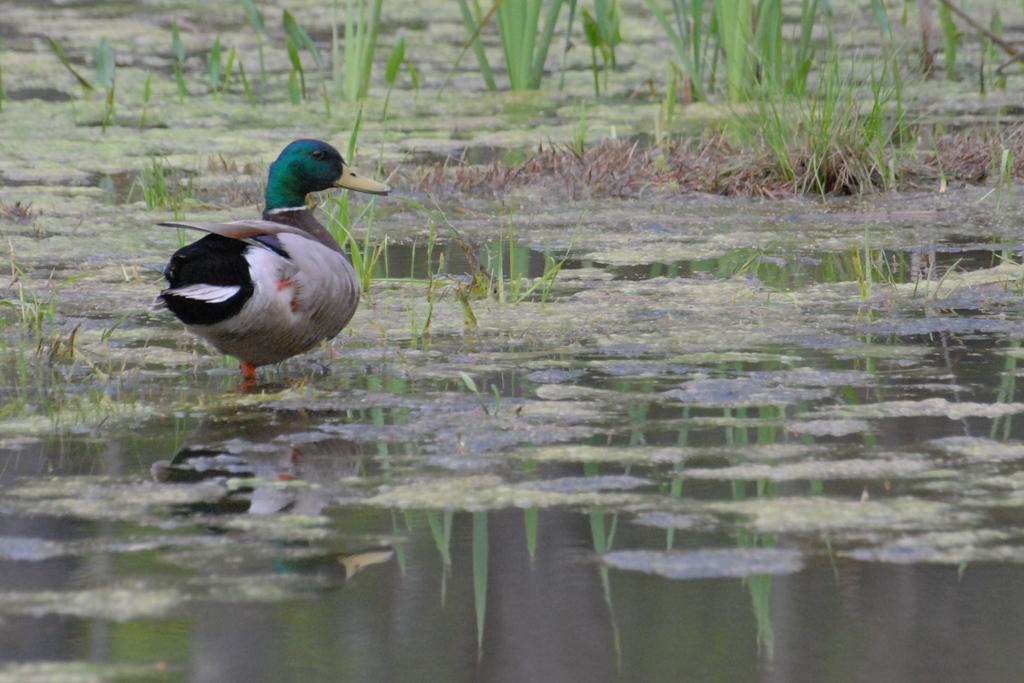What type of animal can be seen in the image? There is a bird in the image. What is the bird situated in? The bird is situated in water. What type of vegetation can be seen in the water? There are grass plants in the water in the image. What type of horn can be seen on the bird in the image? There is no horn present on the bird in the image. 